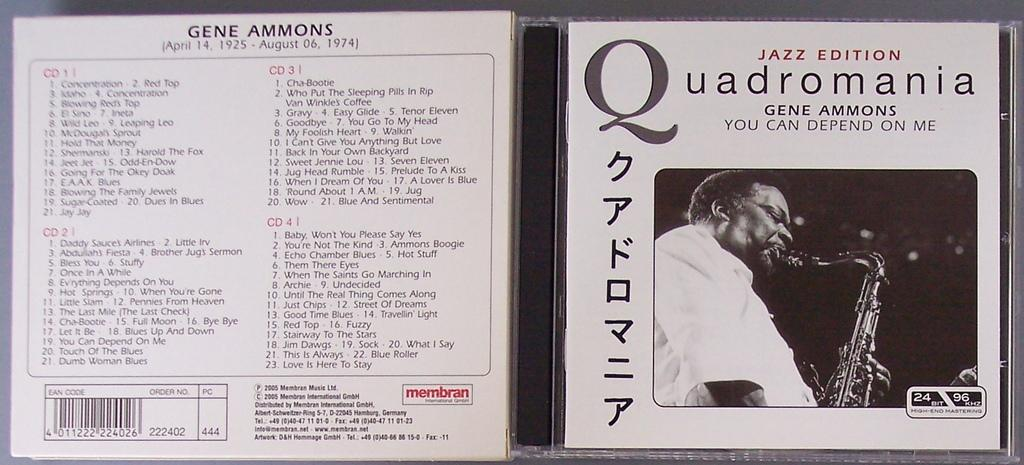Provide a one-sentence caption for the provided image. A Jazz compact disc titled "Quadromania" with Japanese lettering. 